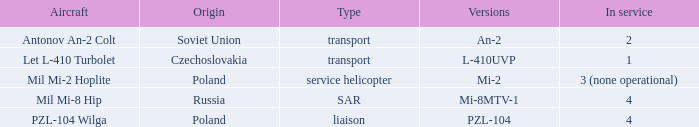Could you parse the entire table? {'header': ['Aircraft', 'Origin', 'Type', 'Versions', 'In service'], 'rows': [['Antonov An-2 Colt', 'Soviet Union', 'transport', 'An-2', '2'], ['Let L-410 Turbolet', 'Czechoslovakia', 'transport', 'L-410UVP', '1'], ['Mil Mi-2 Hoplite', 'Poland', 'service helicopter', 'Mi-2', '3 (none operational)'], ['Mil Mi-8 Hip', 'Russia', 'SAR', 'Mi-8MTV-1', '4'], ['PZL-104 Wilga', 'Poland', 'liaison', 'PZL-104', '4']]} List the multiple variations related to czechoslovakia. L-410UVP. 